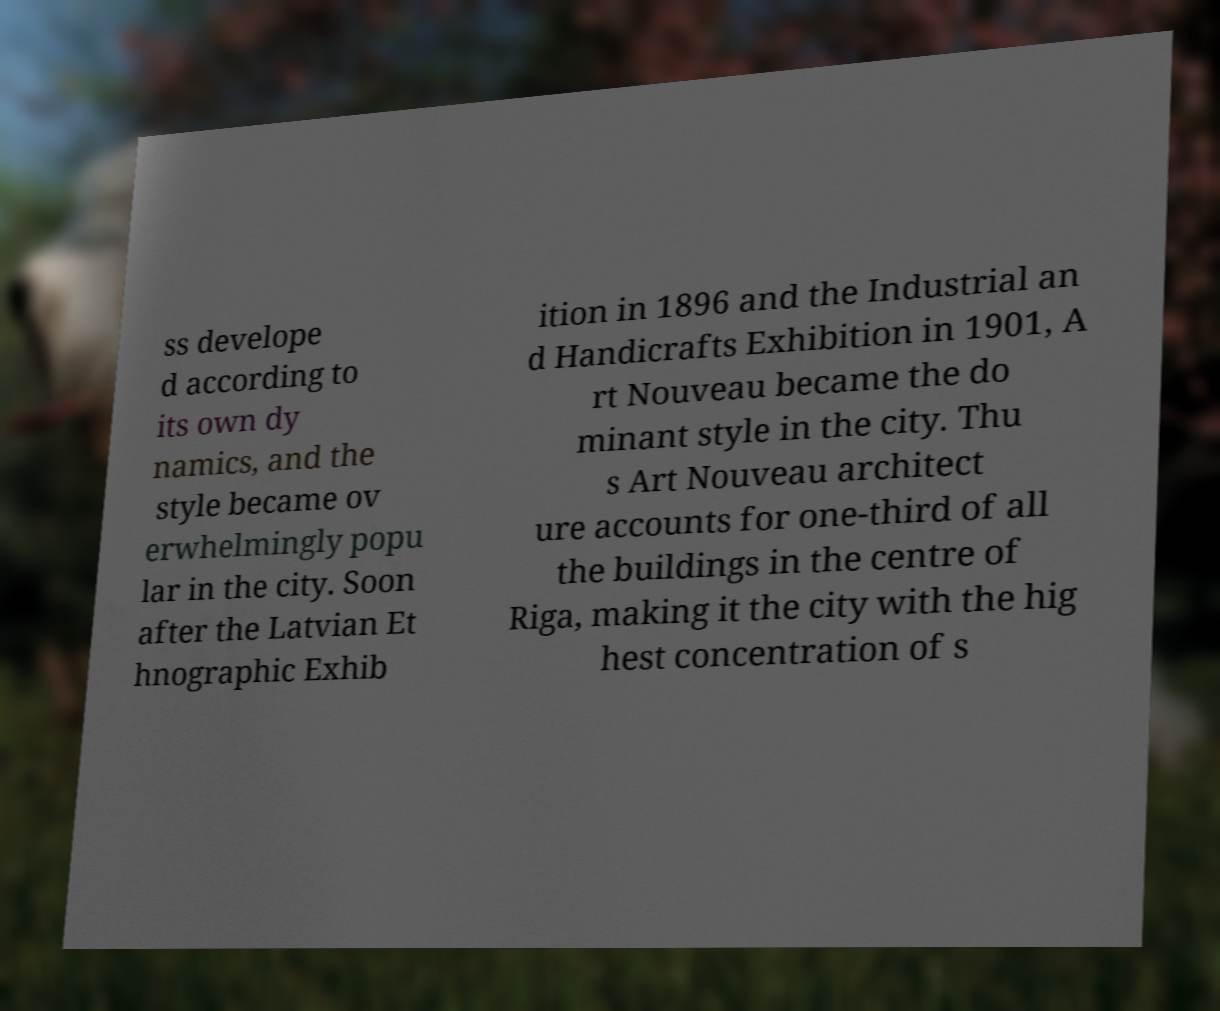For documentation purposes, I need the text within this image transcribed. Could you provide that? ss develope d according to its own dy namics, and the style became ov erwhelmingly popu lar in the city. Soon after the Latvian Et hnographic Exhib ition in 1896 and the Industrial an d Handicrafts Exhibition in 1901, A rt Nouveau became the do minant style in the city. Thu s Art Nouveau architect ure accounts for one-third of all the buildings in the centre of Riga, making it the city with the hig hest concentration of s 